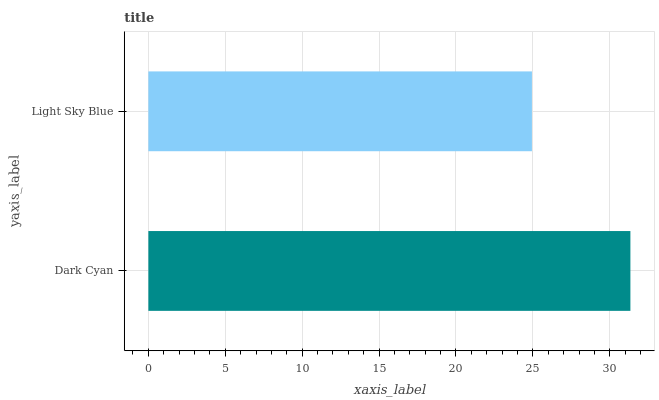Is Light Sky Blue the minimum?
Answer yes or no. Yes. Is Dark Cyan the maximum?
Answer yes or no. Yes. Is Light Sky Blue the maximum?
Answer yes or no. No. Is Dark Cyan greater than Light Sky Blue?
Answer yes or no. Yes. Is Light Sky Blue less than Dark Cyan?
Answer yes or no. Yes. Is Light Sky Blue greater than Dark Cyan?
Answer yes or no. No. Is Dark Cyan less than Light Sky Blue?
Answer yes or no. No. Is Dark Cyan the high median?
Answer yes or no. Yes. Is Light Sky Blue the low median?
Answer yes or no. Yes. Is Light Sky Blue the high median?
Answer yes or no. No. Is Dark Cyan the low median?
Answer yes or no. No. 